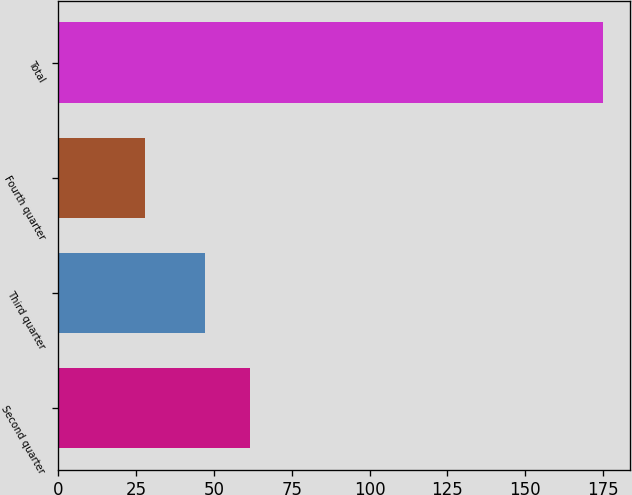<chart> <loc_0><loc_0><loc_500><loc_500><bar_chart><fcel>Second quarter<fcel>Third quarter<fcel>Fourth quarter<fcel>Total<nl><fcel>61.7<fcel>47<fcel>28<fcel>175<nl></chart> 